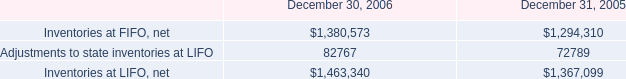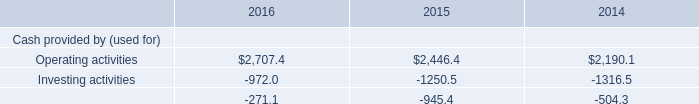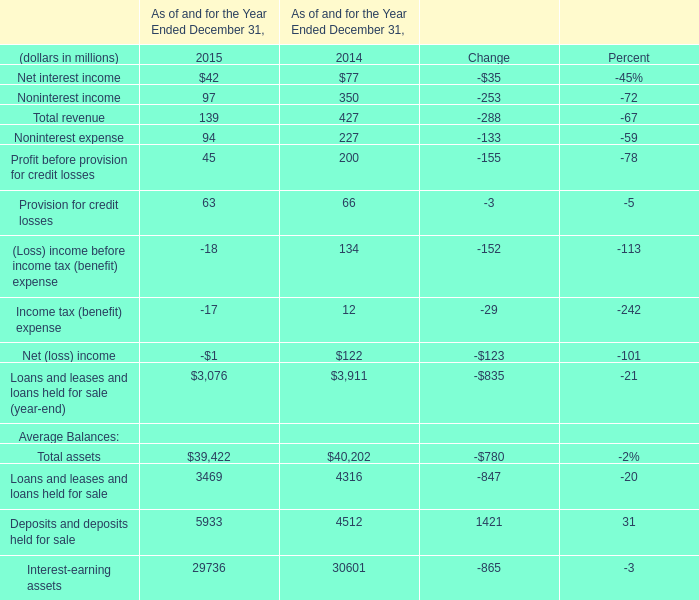what was the percentage change in reserves against inventory from 2005 to 2006? 
Computations: ((31376 - 22825) / 22825)
Answer: 0.37463. 